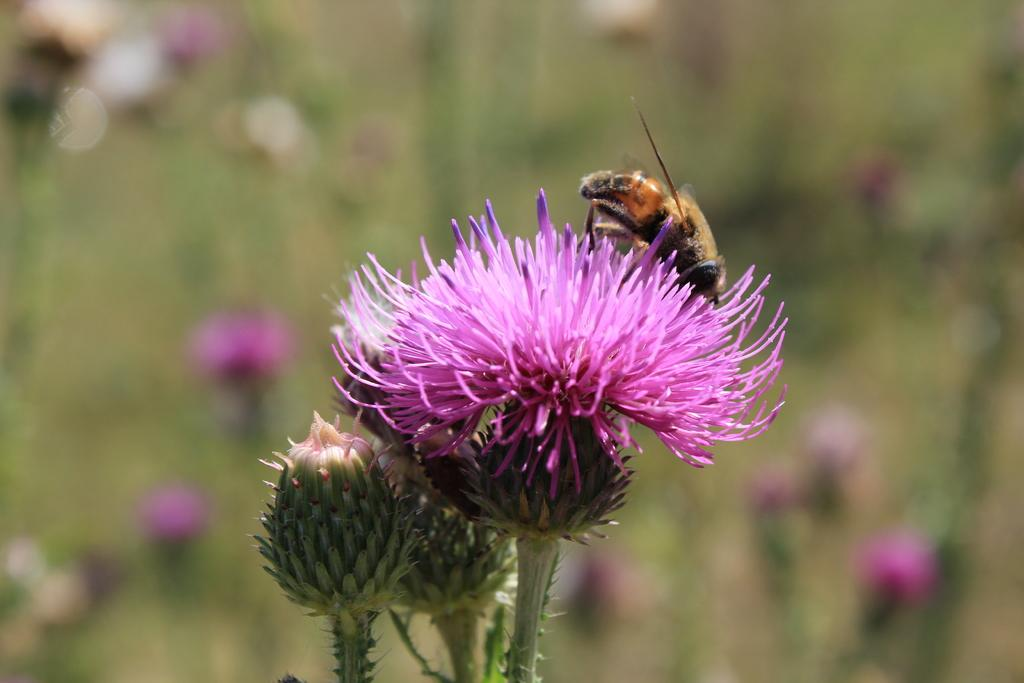What type of plant can be seen in the image? There is a flower in the image. Are there any unopened parts of the flower visible? Yes, there are flower buds in the image. What other living organism is present in the image? There is an insect in the image. How would you describe the background of the image? The background of the image is blurry. What type of treatment is the flower receiving in the image? There is no indication in the image that the flower is receiving any treatment. 